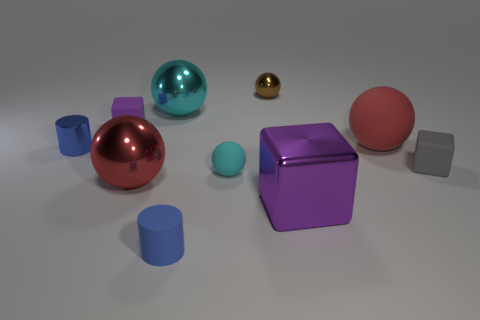What is the shape of the tiny object that is the same color as the big metal block?
Provide a short and direct response. Cube. How many other things are made of the same material as the big cyan thing?
Offer a terse response. 4. What is the size of the blue matte cylinder?
Your answer should be compact. Small. Are there any small purple objects of the same shape as the big cyan object?
Provide a short and direct response. No. How many things are cubes or blocks that are right of the blue matte object?
Give a very brief answer. 3. What color is the object in front of the purple metallic block?
Keep it short and to the point. Blue. Do the blue metallic cylinder that is in front of the big cyan sphere and the red thing that is to the right of the shiny block have the same size?
Make the answer very short. No. Are there any blue rubber cylinders that have the same size as the brown thing?
Keep it short and to the point. Yes. How many small cyan things are on the right side of the big red ball that is behind the tiny gray rubber block?
Provide a short and direct response. 0. What material is the gray block?
Your response must be concise. Rubber. 